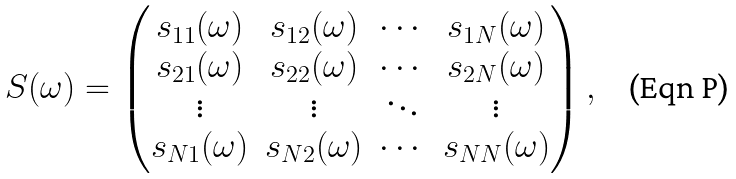<formula> <loc_0><loc_0><loc_500><loc_500>S ( \omega ) = \left ( \begin{matrix} s _ { 1 1 } ( \omega ) & s _ { 1 2 } ( \omega ) & \cdots & s _ { 1 N } ( \omega ) \\ s _ { 2 1 } ( \omega ) & s _ { 2 2 } ( \omega ) & \cdots & s _ { 2 N } ( \omega ) \\ \vdots & \vdots & \ddots & \vdots \\ s _ { N 1 } ( \omega ) & s _ { N 2 } ( \omega ) & \cdots & s _ { N N } ( \omega ) \end{matrix} \right ) ,</formula> 